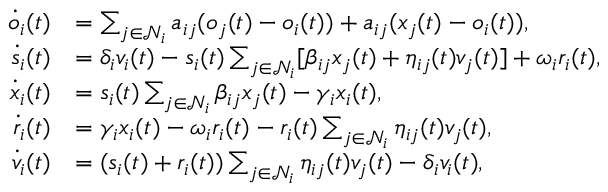Convert formula to latex. <formula><loc_0><loc_0><loc_500><loc_500>\begin{array} { r l } { \dot { o } _ { i } ( t ) } & { = \sum _ { j \in \mathcal { N } _ { i } } a _ { i j } ( o _ { j } ( t ) - o _ { i } ( t ) ) + a _ { i j } ( x _ { j } ( t ) - o _ { i } ( t ) ) , } \\ { \dot { s } _ { i } ( t ) } & { = \delta _ { i } v _ { i } ( t ) - s _ { i } ( t ) \sum _ { j \in \mathcal { N } _ { i } } [ \beta _ { i j } x _ { j } ( t ) + \eta _ { i j } ( t ) v _ { j } ( t ) ] + \omega _ { i } r _ { i } ( t ) , } \\ { \dot { x } _ { i } ( t ) } & { = s _ { i } ( t ) \sum _ { j \in \mathcal { N } _ { i } } \beta _ { i j } x _ { j } ( t ) - \gamma _ { i } x _ { i } ( t ) , } \\ { \dot { r } _ { i } ( t ) } & { = \gamma _ { i } x _ { i } ( t ) - \omega _ { i } r _ { i } ( t ) - r _ { i } ( t ) \sum _ { j \in \mathcal { N } _ { i } } \eta _ { i j } ( t ) v _ { j } ( t ) , } \\ { \dot { v } _ { i } ( t ) } & { = ( s _ { i } ( t ) + r _ { i } ( t ) ) \sum _ { j \in \mathcal { N } _ { i } } \eta _ { i j } ( t ) v _ { j } ( t ) - \delta _ { i } v _ { i } ( t ) , } \end{array}</formula> 